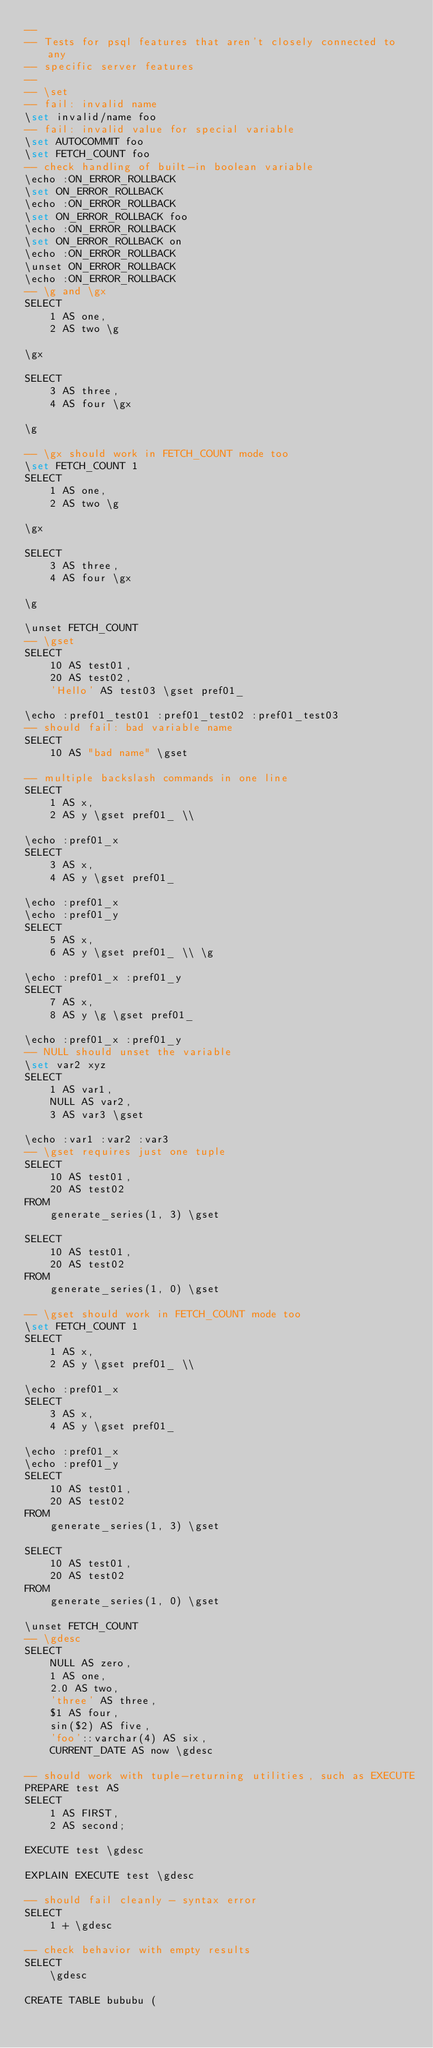Convert code to text. <code><loc_0><loc_0><loc_500><loc_500><_SQL_>--
-- Tests for psql features that aren't closely connected to any
-- specific server features
--
-- \set
-- fail: invalid name
\set invalid/name foo
-- fail: invalid value for special variable
\set AUTOCOMMIT foo
\set FETCH_COUNT foo
-- check handling of built-in boolean variable
\echo :ON_ERROR_ROLLBACK
\set ON_ERROR_ROLLBACK
\echo :ON_ERROR_ROLLBACK
\set ON_ERROR_ROLLBACK foo
\echo :ON_ERROR_ROLLBACK
\set ON_ERROR_ROLLBACK on
\echo :ON_ERROR_ROLLBACK
\unset ON_ERROR_ROLLBACK
\echo :ON_ERROR_ROLLBACK
-- \g and \gx
SELECT
    1 AS one,
    2 AS two \g

\gx

SELECT
    3 AS three,
    4 AS four \gx

\g

-- \gx should work in FETCH_COUNT mode too
\set FETCH_COUNT 1
SELECT
    1 AS one,
    2 AS two \g

\gx

SELECT
    3 AS three,
    4 AS four \gx

\g

\unset FETCH_COUNT
-- \gset
SELECT
    10 AS test01,
    20 AS test02,
    'Hello' AS test03 \gset pref01_

\echo :pref01_test01 :pref01_test02 :pref01_test03
-- should fail: bad variable name
SELECT
    10 AS "bad name" \gset

-- multiple backslash commands in one line
SELECT
    1 AS x,
    2 AS y \gset pref01_ \\ 

\echo :pref01_x
SELECT
    3 AS x,
    4 AS y \gset pref01_ 

\echo :pref01_x 
\echo :pref01_y
SELECT
    5 AS x,
    6 AS y \gset pref01_ \\ \g 

\echo :pref01_x :pref01_y
SELECT
    7 AS x,
    8 AS y \g \gset pref01_ 

\echo :pref01_x :pref01_y
-- NULL should unset the variable
\set var2 xyz
SELECT
    1 AS var1,
    NULL AS var2,
    3 AS var3 \gset

\echo :var1 :var2 :var3
-- \gset requires just one tuple
SELECT
    10 AS test01,
    20 AS test02
FROM
    generate_series(1, 3) \gset

SELECT
    10 AS test01,
    20 AS test02
FROM
    generate_series(1, 0) \gset

-- \gset should work in FETCH_COUNT mode too
\set FETCH_COUNT 1
SELECT
    1 AS x,
    2 AS y \gset pref01_ \\ 

\echo :pref01_x
SELECT
    3 AS x,
    4 AS y \gset pref01_ 

\echo :pref01_x 
\echo :pref01_y
SELECT
    10 AS test01,
    20 AS test02
FROM
    generate_series(1, 3) \gset

SELECT
    10 AS test01,
    20 AS test02
FROM
    generate_series(1, 0) \gset

\unset FETCH_COUNT
-- \gdesc
SELECT
    NULL AS zero,
    1 AS one,
    2.0 AS two,
    'three' AS three,
    $1 AS four,
    sin($2) AS five,
    'foo'::varchar(4) AS six,
    CURRENT_DATE AS now \gdesc

-- should work with tuple-returning utilities, such as EXECUTE
PREPARE test AS
SELECT
    1 AS FIRST,
    2 AS second;

EXECUTE test \gdesc

EXPLAIN EXECUTE test \gdesc

-- should fail cleanly - syntax error
SELECT
    1 + \gdesc

-- check behavior with empty results
SELECT
    \gdesc

CREATE TABLE bububu (</code> 